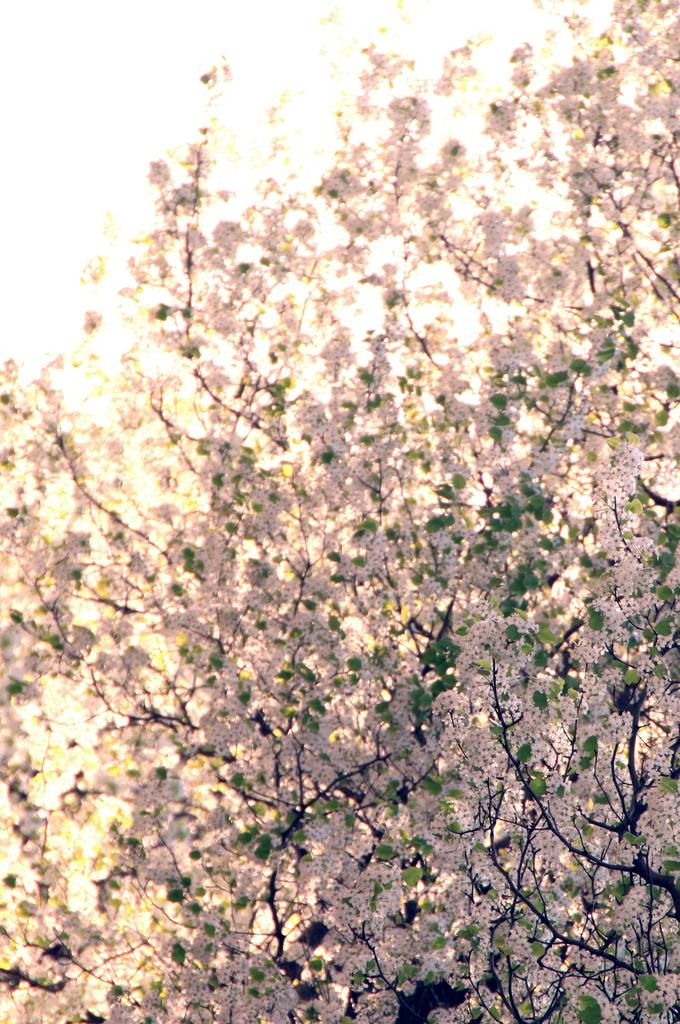What type of plant can be seen in the image? There is a tree in the image. What additional features can be observed on the tree? There are flowers and leaves in the image. How many children are playing around the tree in the image? There are no children present in the image; it only features a tree with flowers and leaves. 